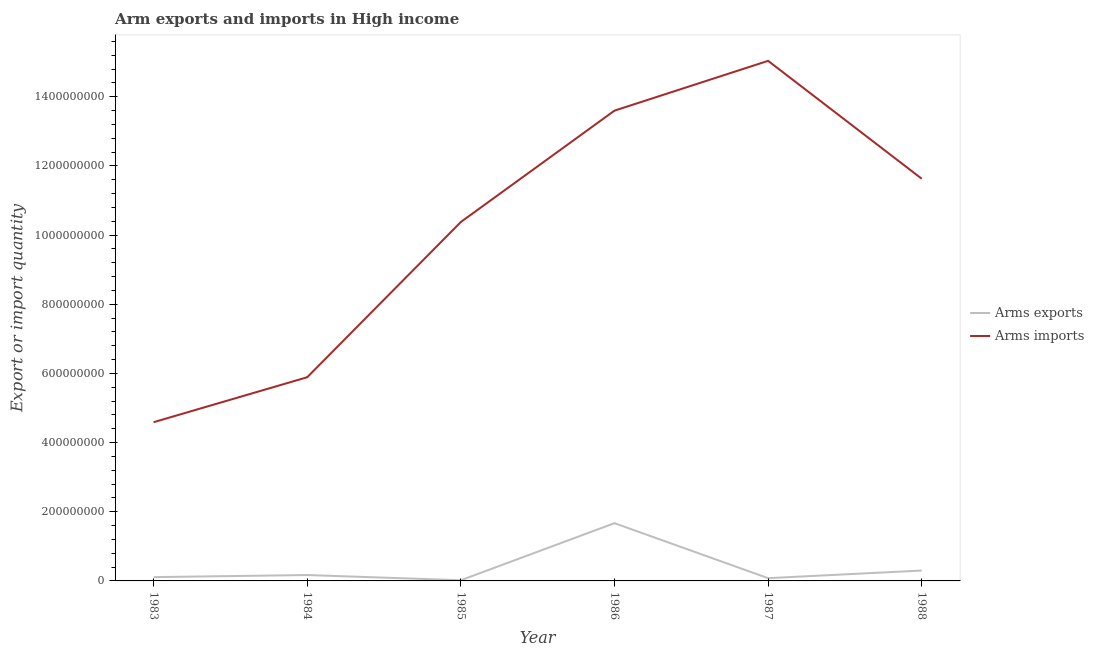What is the arms imports in 1987?
Your answer should be compact. 1.50e+09. Across all years, what is the maximum arms imports?
Keep it short and to the point. 1.50e+09. Across all years, what is the minimum arms imports?
Provide a succinct answer. 4.59e+08. In which year was the arms imports maximum?
Provide a succinct answer. 1987. What is the total arms imports in the graph?
Provide a succinct answer. 6.11e+09. What is the difference between the arms imports in 1983 and that in 1986?
Give a very brief answer. -9.01e+08. What is the difference between the arms exports in 1984 and the arms imports in 1983?
Your answer should be compact. -4.42e+08. What is the average arms exports per year?
Your answer should be very brief. 3.92e+07. In the year 1984, what is the difference between the arms imports and arms exports?
Ensure brevity in your answer.  5.72e+08. What is the ratio of the arms exports in 1984 to that in 1985?
Make the answer very short. 8.5. Is the arms imports in 1984 less than that in 1986?
Provide a succinct answer. Yes. What is the difference between the highest and the second highest arms imports?
Your answer should be compact. 1.44e+08. What is the difference between the highest and the lowest arms exports?
Offer a very short reply. 1.65e+08. Is the sum of the arms imports in 1984 and 1988 greater than the maximum arms exports across all years?
Offer a terse response. Yes. Does the arms imports monotonically increase over the years?
Ensure brevity in your answer.  No. Is the arms imports strictly greater than the arms exports over the years?
Offer a terse response. Yes. Is the arms exports strictly less than the arms imports over the years?
Ensure brevity in your answer.  Yes. How many lines are there?
Provide a succinct answer. 2. Does the graph contain any zero values?
Your answer should be compact. No. Where does the legend appear in the graph?
Offer a very short reply. Center right. How many legend labels are there?
Ensure brevity in your answer.  2. How are the legend labels stacked?
Make the answer very short. Vertical. What is the title of the graph?
Your answer should be very brief. Arm exports and imports in High income. Does "Underweight" appear as one of the legend labels in the graph?
Provide a short and direct response. No. What is the label or title of the Y-axis?
Keep it short and to the point. Export or import quantity. What is the Export or import quantity in Arms exports in 1983?
Offer a terse response. 1.10e+07. What is the Export or import quantity in Arms imports in 1983?
Provide a short and direct response. 4.59e+08. What is the Export or import quantity of Arms exports in 1984?
Give a very brief answer. 1.70e+07. What is the Export or import quantity of Arms imports in 1984?
Make the answer very short. 5.89e+08. What is the Export or import quantity of Arms exports in 1985?
Provide a succinct answer. 2.00e+06. What is the Export or import quantity in Arms imports in 1985?
Offer a very short reply. 1.04e+09. What is the Export or import quantity in Arms exports in 1986?
Make the answer very short. 1.67e+08. What is the Export or import quantity in Arms imports in 1986?
Offer a terse response. 1.36e+09. What is the Export or import quantity in Arms imports in 1987?
Offer a very short reply. 1.50e+09. What is the Export or import quantity in Arms exports in 1988?
Keep it short and to the point. 3.00e+07. What is the Export or import quantity of Arms imports in 1988?
Offer a terse response. 1.16e+09. Across all years, what is the maximum Export or import quantity of Arms exports?
Offer a terse response. 1.67e+08. Across all years, what is the maximum Export or import quantity of Arms imports?
Make the answer very short. 1.50e+09. Across all years, what is the minimum Export or import quantity of Arms imports?
Give a very brief answer. 4.59e+08. What is the total Export or import quantity of Arms exports in the graph?
Your answer should be compact. 2.35e+08. What is the total Export or import quantity in Arms imports in the graph?
Make the answer very short. 6.11e+09. What is the difference between the Export or import quantity in Arms exports in 1983 and that in 1984?
Provide a succinct answer. -6.00e+06. What is the difference between the Export or import quantity in Arms imports in 1983 and that in 1984?
Provide a short and direct response. -1.30e+08. What is the difference between the Export or import quantity of Arms exports in 1983 and that in 1985?
Keep it short and to the point. 9.00e+06. What is the difference between the Export or import quantity of Arms imports in 1983 and that in 1985?
Your response must be concise. -5.79e+08. What is the difference between the Export or import quantity of Arms exports in 1983 and that in 1986?
Offer a very short reply. -1.56e+08. What is the difference between the Export or import quantity in Arms imports in 1983 and that in 1986?
Make the answer very short. -9.01e+08. What is the difference between the Export or import quantity in Arms exports in 1983 and that in 1987?
Ensure brevity in your answer.  3.00e+06. What is the difference between the Export or import quantity of Arms imports in 1983 and that in 1987?
Offer a terse response. -1.04e+09. What is the difference between the Export or import quantity in Arms exports in 1983 and that in 1988?
Provide a short and direct response. -1.90e+07. What is the difference between the Export or import quantity in Arms imports in 1983 and that in 1988?
Make the answer very short. -7.04e+08. What is the difference between the Export or import quantity in Arms exports in 1984 and that in 1985?
Ensure brevity in your answer.  1.50e+07. What is the difference between the Export or import quantity in Arms imports in 1984 and that in 1985?
Make the answer very short. -4.49e+08. What is the difference between the Export or import quantity in Arms exports in 1984 and that in 1986?
Provide a succinct answer. -1.50e+08. What is the difference between the Export or import quantity in Arms imports in 1984 and that in 1986?
Your answer should be compact. -7.71e+08. What is the difference between the Export or import quantity of Arms exports in 1984 and that in 1987?
Give a very brief answer. 9.00e+06. What is the difference between the Export or import quantity of Arms imports in 1984 and that in 1987?
Make the answer very short. -9.15e+08. What is the difference between the Export or import quantity of Arms exports in 1984 and that in 1988?
Provide a succinct answer. -1.30e+07. What is the difference between the Export or import quantity in Arms imports in 1984 and that in 1988?
Your answer should be compact. -5.74e+08. What is the difference between the Export or import quantity in Arms exports in 1985 and that in 1986?
Keep it short and to the point. -1.65e+08. What is the difference between the Export or import quantity in Arms imports in 1985 and that in 1986?
Provide a short and direct response. -3.22e+08. What is the difference between the Export or import quantity in Arms exports in 1985 and that in 1987?
Offer a very short reply. -6.00e+06. What is the difference between the Export or import quantity in Arms imports in 1985 and that in 1987?
Provide a short and direct response. -4.66e+08. What is the difference between the Export or import quantity of Arms exports in 1985 and that in 1988?
Offer a very short reply. -2.80e+07. What is the difference between the Export or import quantity in Arms imports in 1985 and that in 1988?
Your answer should be very brief. -1.25e+08. What is the difference between the Export or import quantity in Arms exports in 1986 and that in 1987?
Offer a very short reply. 1.59e+08. What is the difference between the Export or import quantity of Arms imports in 1986 and that in 1987?
Make the answer very short. -1.44e+08. What is the difference between the Export or import quantity in Arms exports in 1986 and that in 1988?
Offer a very short reply. 1.37e+08. What is the difference between the Export or import quantity of Arms imports in 1986 and that in 1988?
Keep it short and to the point. 1.97e+08. What is the difference between the Export or import quantity in Arms exports in 1987 and that in 1988?
Keep it short and to the point. -2.20e+07. What is the difference between the Export or import quantity of Arms imports in 1987 and that in 1988?
Your response must be concise. 3.41e+08. What is the difference between the Export or import quantity of Arms exports in 1983 and the Export or import quantity of Arms imports in 1984?
Your answer should be very brief. -5.78e+08. What is the difference between the Export or import quantity of Arms exports in 1983 and the Export or import quantity of Arms imports in 1985?
Your answer should be very brief. -1.03e+09. What is the difference between the Export or import quantity in Arms exports in 1983 and the Export or import quantity in Arms imports in 1986?
Offer a terse response. -1.35e+09. What is the difference between the Export or import quantity in Arms exports in 1983 and the Export or import quantity in Arms imports in 1987?
Make the answer very short. -1.49e+09. What is the difference between the Export or import quantity in Arms exports in 1983 and the Export or import quantity in Arms imports in 1988?
Ensure brevity in your answer.  -1.15e+09. What is the difference between the Export or import quantity in Arms exports in 1984 and the Export or import quantity in Arms imports in 1985?
Your response must be concise. -1.02e+09. What is the difference between the Export or import quantity in Arms exports in 1984 and the Export or import quantity in Arms imports in 1986?
Your response must be concise. -1.34e+09. What is the difference between the Export or import quantity of Arms exports in 1984 and the Export or import quantity of Arms imports in 1987?
Give a very brief answer. -1.49e+09. What is the difference between the Export or import quantity of Arms exports in 1984 and the Export or import quantity of Arms imports in 1988?
Keep it short and to the point. -1.15e+09. What is the difference between the Export or import quantity in Arms exports in 1985 and the Export or import quantity in Arms imports in 1986?
Make the answer very short. -1.36e+09. What is the difference between the Export or import quantity in Arms exports in 1985 and the Export or import quantity in Arms imports in 1987?
Your response must be concise. -1.50e+09. What is the difference between the Export or import quantity in Arms exports in 1985 and the Export or import quantity in Arms imports in 1988?
Keep it short and to the point. -1.16e+09. What is the difference between the Export or import quantity of Arms exports in 1986 and the Export or import quantity of Arms imports in 1987?
Your answer should be compact. -1.34e+09. What is the difference between the Export or import quantity of Arms exports in 1986 and the Export or import quantity of Arms imports in 1988?
Make the answer very short. -9.96e+08. What is the difference between the Export or import quantity in Arms exports in 1987 and the Export or import quantity in Arms imports in 1988?
Keep it short and to the point. -1.16e+09. What is the average Export or import quantity of Arms exports per year?
Your response must be concise. 3.92e+07. What is the average Export or import quantity in Arms imports per year?
Ensure brevity in your answer.  1.02e+09. In the year 1983, what is the difference between the Export or import quantity in Arms exports and Export or import quantity in Arms imports?
Give a very brief answer. -4.48e+08. In the year 1984, what is the difference between the Export or import quantity in Arms exports and Export or import quantity in Arms imports?
Make the answer very short. -5.72e+08. In the year 1985, what is the difference between the Export or import quantity in Arms exports and Export or import quantity in Arms imports?
Ensure brevity in your answer.  -1.04e+09. In the year 1986, what is the difference between the Export or import quantity in Arms exports and Export or import quantity in Arms imports?
Make the answer very short. -1.19e+09. In the year 1987, what is the difference between the Export or import quantity of Arms exports and Export or import quantity of Arms imports?
Make the answer very short. -1.50e+09. In the year 1988, what is the difference between the Export or import quantity of Arms exports and Export or import quantity of Arms imports?
Your answer should be very brief. -1.13e+09. What is the ratio of the Export or import quantity in Arms exports in 1983 to that in 1984?
Provide a succinct answer. 0.65. What is the ratio of the Export or import quantity of Arms imports in 1983 to that in 1984?
Provide a short and direct response. 0.78. What is the ratio of the Export or import quantity of Arms imports in 1983 to that in 1985?
Provide a short and direct response. 0.44. What is the ratio of the Export or import quantity of Arms exports in 1983 to that in 1986?
Offer a very short reply. 0.07. What is the ratio of the Export or import quantity of Arms imports in 1983 to that in 1986?
Your answer should be very brief. 0.34. What is the ratio of the Export or import quantity of Arms exports in 1983 to that in 1987?
Offer a very short reply. 1.38. What is the ratio of the Export or import quantity in Arms imports in 1983 to that in 1987?
Provide a short and direct response. 0.31. What is the ratio of the Export or import quantity in Arms exports in 1983 to that in 1988?
Make the answer very short. 0.37. What is the ratio of the Export or import quantity of Arms imports in 1983 to that in 1988?
Your answer should be compact. 0.39. What is the ratio of the Export or import quantity of Arms imports in 1984 to that in 1985?
Keep it short and to the point. 0.57. What is the ratio of the Export or import quantity of Arms exports in 1984 to that in 1986?
Your answer should be very brief. 0.1. What is the ratio of the Export or import quantity of Arms imports in 1984 to that in 1986?
Make the answer very short. 0.43. What is the ratio of the Export or import quantity in Arms exports in 1984 to that in 1987?
Keep it short and to the point. 2.12. What is the ratio of the Export or import quantity of Arms imports in 1984 to that in 1987?
Give a very brief answer. 0.39. What is the ratio of the Export or import quantity of Arms exports in 1984 to that in 1988?
Keep it short and to the point. 0.57. What is the ratio of the Export or import quantity in Arms imports in 1984 to that in 1988?
Ensure brevity in your answer.  0.51. What is the ratio of the Export or import quantity of Arms exports in 1985 to that in 1986?
Your answer should be very brief. 0.01. What is the ratio of the Export or import quantity of Arms imports in 1985 to that in 1986?
Your answer should be very brief. 0.76. What is the ratio of the Export or import quantity of Arms imports in 1985 to that in 1987?
Your answer should be very brief. 0.69. What is the ratio of the Export or import quantity in Arms exports in 1985 to that in 1988?
Offer a very short reply. 0.07. What is the ratio of the Export or import quantity in Arms imports in 1985 to that in 1988?
Keep it short and to the point. 0.89. What is the ratio of the Export or import quantity in Arms exports in 1986 to that in 1987?
Provide a succinct answer. 20.88. What is the ratio of the Export or import quantity in Arms imports in 1986 to that in 1987?
Provide a succinct answer. 0.9. What is the ratio of the Export or import quantity in Arms exports in 1986 to that in 1988?
Offer a terse response. 5.57. What is the ratio of the Export or import quantity of Arms imports in 1986 to that in 1988?
Offer a terse response. 1.17. What is the ratio of the Export or import quantity in Arms exports in 1987 to that in 1988?
Give a very brief answer. 0.27. What is the ratio of the Export or import quantity of Arms imports in 1987 to that in 1988?
Your answer should be very brief. 1.29. What is the difference between the highest and the second highest Export or import quantity in Arms exports?
Your response must be concise. 1.37e+08. What is the difference between the highest and the second highest Export or import quantity of Arms imports?
Keep it short and to the point. 1.44e+08. What is the difference between the highest and the lowest Export or import quantity of Arms exports?
Keep it short and to the point. 1.65e+08. What is the difference between the highest and the lowest Export or import quantity in Arms imports?
Ensure brevity in your answer.  1.04e+09. 